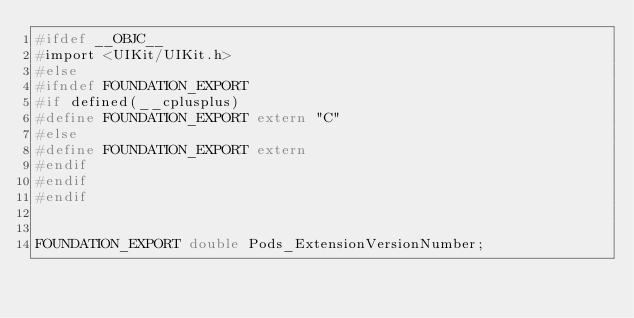<code> <loc_0><loc_0><loc_500><loc_500><_C_>#ifdef __OBJC__
#import <UIKit/UIKit.h>
#else
#ifndef FOUNDATION_EXPORT
#if defined(__cplusplus)
#define FOUNDATION_EXPORT extern "C"
#else
#define FOUNDATION_EXPORT extern
#endif
#endif
#endif


FOUNDATION_EXPORT double Pods_ExtensionVersionNumber;</code> 